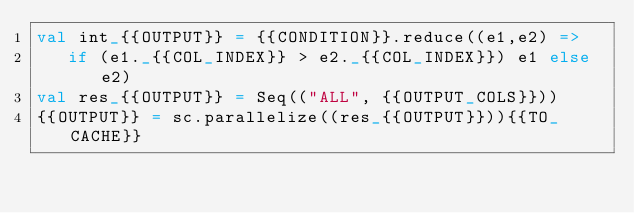Convert code to text. <code><loc_0><loc_0><loc_500><loc_500><_Scala_>val int_{{OUTPUT}} = {{CONDITION}}.reduce((e1,e2) =>
   if (e1._{{COL_INDEX}} > e2._{{COL_INDEX}}) e1 else e2)
val res_{{OUTPUT}} = Seq(("ALL", {{OUTPUT_COLS}}))
{{OUTPUT}} = sc.parallelize((res_{{OUTPUT}})){{TO_CACHE}}

</code> 